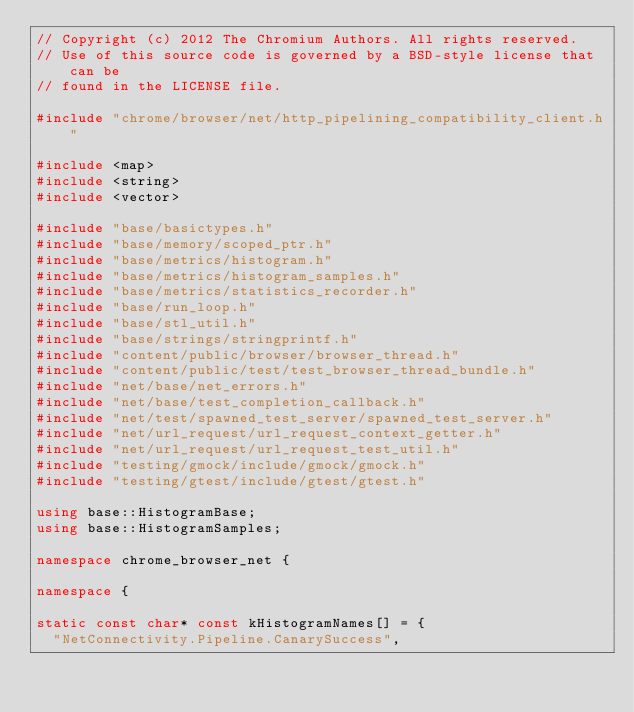Convert code to text. <code><loc_0><loc_0><loc_500><loc_500><_C++_>// Copyright (c) 2012 The Chromium Authors. All rights reserved.
// Use of this source code is governed by a BSD-style license that can be
// found in the LICENSE file.

#include "chrome/browser/net/http_pipelining_compatibility_client.h"

#include <map>
#include <string>
#include <vector>

#include "base/basictypes.h"
#include "base/memory/scoped_ptr.h"
#include "base/metrics/histogram.h"
#include "base/metrics/histogram_samples.h"
#include "base/metrics/statistics_recorder.h"
#include "base/run_loop.h"
#include "base/stl_util.h"
#include "base/strings/stringprintf.h"
#include "content/public/browser/browser_thread.h"
#include "content/public/test/test_browser_thread_bundle.h"
#include "net/base/net_errors.h"
#include "net/base/test_completion_callback.h"
#include "net/test/spawned_test_server/spawned_test_server.h"
#include "net/url_request/url_request_context_getter.h"
#include "net/url_request/url_request_test_util.h"
#include "testing/gmock/include/gmock/gmock.h"
#include "testing/gtest/include/gtest/gtest.h"

using base::HistogramBase;
using base::HistogramSamples;

namespace chrome_browser_net {

namespace {

static const char* const kHistogramNames[] = {
  "NetConnectivity.Pipeline.CanarySuccess",</code> 